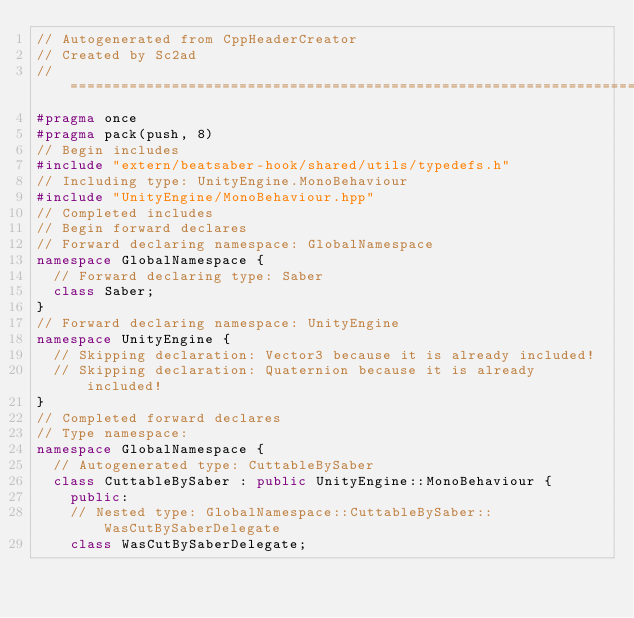<code> <loc_0><loc_0><loc_500><loc_500><_C++_>// Autogenerated from CppHeaderCreator
// Created by Sc2ad
// =========================================================================
#pragma once
#pragma pack(push, 8)
// Begin includes
#include "extern/beatsaber-hook/shared/utils/typedefs.h"
// Including type: UnityEngine.MonoBehaviour
#include "UnityEngine/MonoBehaviour.hpp"
// Completed includes
// Begin forward declares
// Forward declaring namespace: GlobalNamespace
namespace GlobalNamespace {
  // Forward declaring type: Saber
  class Saber;
}
// Forward declaring namespace: UnityEngine
namespace UnityEngine {
  // Skipping declaration: Vector3 because it is already included!
  // Skipping declaration: Quaternion because it is already included!
}
// Completed forward declares
// Type namespace: 
namespace GlobalNamespace {
  // Autogenerated type: CuttableBySaber
  class CuttableBySaber : public UnityEngine::MonoBehaviour {
    public:
    // Nested type: GlobalNamespace::CuttableBySaber::WasCutBySaberDelegate
    class WasCutBySaberDelegate;</code> 